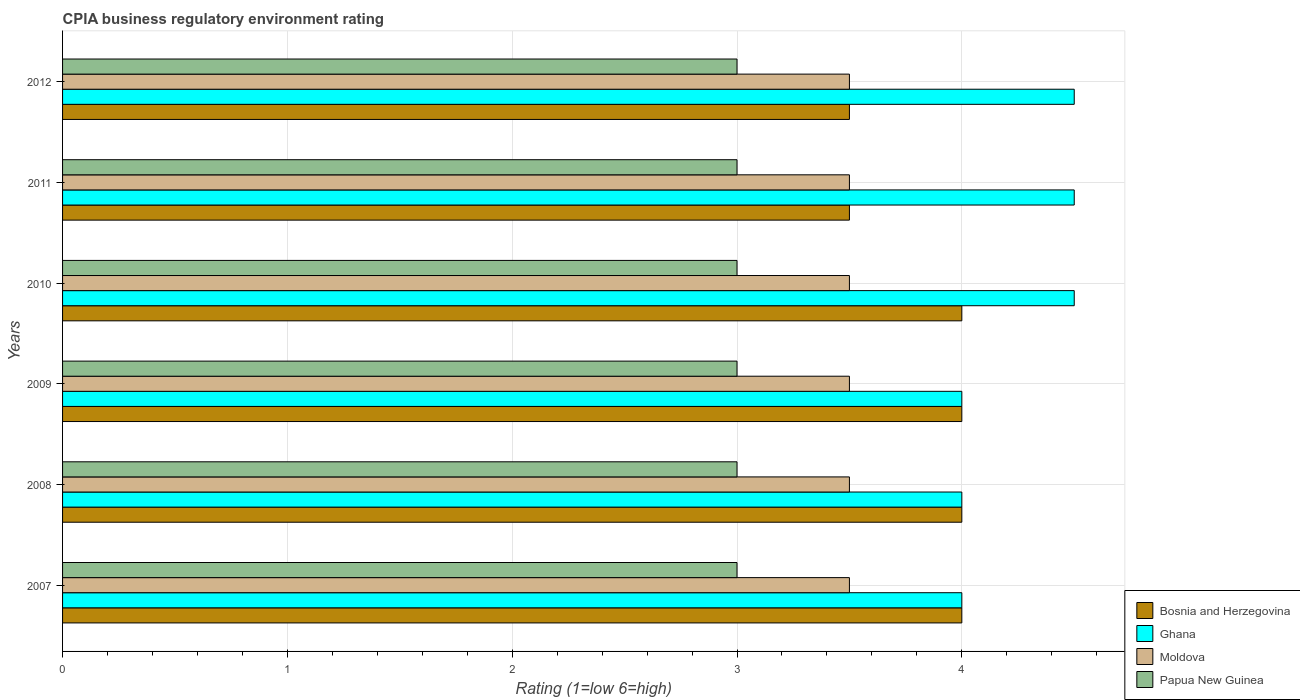How many different coloured bars are there?
Offer a terse response. 4. How many groups of bars are there?
Offer a very short reply. 6. Are the number of bars per tick equal to the number of legend labels?
Provide a succinct answer. Yes. Are the number of bars on each tick of the Y-axis equal?
Offer a very short reply. Yes. In how many cases, is the number of bars for a given year not equal to the number of legend labels?
Provide a succinct answer. 0. What is the CPIA rating in Moldova in 2008?
Your response must be concise. 3.5. Across all years, what is the maximum CPIA rating in Papua New Guinea?
Your answer should be very brief. 3. In which year was the CPIA rating in Papua New Guinea maximum?
Provide a succinct answer. 2007. In which year was the CPIA rating in Papua New Guinea minimum?
Ensure brevity in your answer.  2007. What is the average CPIA rating in Papua New Guinea per year?
Ensure brevity in your answer.  3. In how many years, is the CPIA rating in Ghana greater than 2.8 ?
Keep it short and to the point. 6. Is the CPIA rating in Moldova in 2009 less than that in 2012?
Your answer should be very brief. No. Is the difference between the CPIA rating in Ghana in 2007 and 2011 greater than the difference between the CPIA rating in Papua New Guinea in 2007 and 2011?
Provide a succinct answer. No. What is the difference between the highest and the second highest CPIA rating in Moldova?
Give a very brief answer. 0. What is the difference between the highest and the lowest CPIA rating in Bosnia and Herzegovina?
Give a very brief answer. 0.5. What does the 4th bar from the top in 2010 represents?
Ensure brevity in your answer.  Bosnia and Herzegovina. What does the 3rd bar from the bottom in 2007 represents?
Your answer should be very brief. Moldova. Are all the bars in the graph horizontal?
Your response must be concise. Yes. How many years are there in the graph?
Keep it short and to the point. 6. What is the difference between two consecutive major ticks on the X-axis?
Make the answer very short. 1. How many legend labels are there?
Your answer should be very brief. 4. What is the title of the graph?
Ensure brevity in your answer.  CPIA business regulatory environment rating. What is the label or title of the X-axis?
Provide a short and direct response. Rating (1=low 6=high). What is the Rating (1=low 6=high) of Bosnia and Herzegovina in 2007?
Give a very brief answer. 4. What is the Rating (1=low 6=high) in Ghana in 2007?
Offer a terse response. 4. What is the Rating (1=low 6=high) in Moldova in 2007?
Make the answer very short. 3.5. What is the Rating (1=low 6=high) in Papua New Guinea in 2007?
Ensure brevity in your answer.  3. What is the Rating (1=low 6=high) in Bosnia and Herzegovina in 2008?
Your answer should be very brief. 4. What is the Rating (1=low 6=high) of Ghana in 2008?
Your answer should be very brief. 4. What is the Rating (1=low 6=high) in Papua New Guinea in 2008?
Your response must be concise. 3. What is the Rating (1=low 6=high) in Bosnia and Herzegovina in 2009?
Provide a succinct answer. 4. What is the Rating (1=low 6=high) of Ghana in 2009?
Offer a terse response. 4. What is the Rating (1=low 6=high) in Moldova in 2009?
Your answer should be very brief. 3.5. What is the Rating (1=low 6=high) of Papua New Guinea in 2009?
Provide a short and direct response. 3. What is the Rating (1=low 6=high) of Ghana in 2010?
Your response must be concise. 4.5. What is the Rating (1=low 6=high) in Moldova in 2010?
Your answer should be compact. 3.5. What is the Rating (1=low 6=high) in Papua New Guinea in 2010?
Provide a succinct answer. 3. What is the Rating (1=low 6=high) of Bosnia and Herzegovina in 2011?
Ensure brevity in your answer.  3.5. What is the Rating (1=low 6=high) in Ghana in 2011?
Provide a short and direct response. 4.5. What is the Rating (1=low 6=high) in Papua New Guinea in 2011?
Give a very brief answer. 3. What is the Rating (1=low 6=high) of Bosnia and Herzegovina in 2012?
Your answer should be compact. 3.5. What is the Rating (1=low 6=high) of Moldova in 2012?
Make the answer very short. 3.5. Across all years, what is the maximum Rating (1=low 6=high) of Bosnia and Herzegovina?
Provide a succinct answer. 4. Across all years, what is the minimum Rating (1=low 6=high) in Bosnia and Herzegovina?
Give a very brief answer. 3.5. Across all years, what is the minimum Rating (1=low 6=high) of Papua New Guinea?
Your answer should be compact. 3. What is the total Rating (1=low 6=high) in Ghana in the graph?
Provide a short and direct response. 25.5. What is the difference between the Rating (1=low 6=high) in Ghana in 2007 and that in 2008?
Give a very brief answer. 0. What is the difference between the Rating (1=low 6=high) in Papua New Guinea in 2007 and that in 2008?
Your answer should be very brief. 0. What is the difference between the Rating (1=low 6=high) of Ghana in 2007 and that in 2009?
Provide a short and direct response. 0. What is the difference between the Rating (1=low 6=high) in Bosnia and Herzegovina in 2007 and that in 2010?
Ensure brevity in your answer.  0. What is the difference between the Rating (1=low 6=high) of Ghana in 2007 and that in 2011?
Offer a very short reply. -0.5. What is the difference between the Rating (1=low 6=high) of Moldova in 2007 and that in 2011?
Your response must be concise. 0. What is the difference between the Rating (1=low 6=high) of Papua New Guinea in 2007 and that in 2011?
Make the answer very short. 0. What is the difference between the Rating (1=low 6=high) of Ghana in 2007 and that in 2012?
Your answer should be very brief. -0.5. What is the difference between the Rating (1=low 6=high) of Moldova in 2008 and that in 2009?
Ensure brevity in your answer.  0. What is the difference between the Rating (1=low 6=high) in Papua New Guinea in 2008 and that in 2009?
Your answer should be compact. 0. What is the difference between the Rating (1=low 6=high) in Ghana in 2008 and that in 2010?
Your answer should be very brief. -0.5. What is the difference between the Rating (1=low 6=high) of Moldova in 2008 and that in 2010?
Offer a terse response. 0. What is the difference between the Rating (1=low 6=high) in Ghana in 2008 and that in 2011?
Make the answer very short. -0.5. What is the difference between the Rating (1=low 6=high) in Moldova in 2008 and that in 2011?
Offer a very short reply. 0. What is the difference between the Rating (1=low 6=high) in Papua New Guinea in 2008 and that in 2011?
Offer a terse response. 0. What is the difference between the Rating (1=low 6=high) of Bosnia and Herzegovina in 2008 and that in 2012?
Make the answer very short. 0.5. What is the difference between the Rating (1=low 6=high) in Ghana in 2008 and that in 2012?
Make the answer very short. -0.5. What is the difference between the Rating (1=low 6=high) of Ghana in 2009 and that in 2010?
Give a very brief answer. -0.5. What is the difference between the Rating (1=low 6=high) of Ghana in 2009 and that in 2011?
Make the answer very short. -0.5. What is the difference between the Rating (1=low 6=high) in Papua New Guinea in 2009 and that in 2011?
Your answer should be compact. 0. What is the difference between the Rating (1=low 6=high) in Ghana in 2009 and that in 2012?
Provide a short and direct response. -0.5. What is the difference between the Rating (1=low 6=high) in Moldova in 2009 and that in 2012?
Provide a short and direct response. 0. What is the difference between the Rating (1=low 6=high) in Papua New Guinea in 2009 and that in 2012?
Ensure brevity in your answer.  0. What is the difference between the Rating (1=low 6=high) in Ghana in 2010 and that in 2011?
Offer a very short reply. 0. What is the difference between the Rating (1=low 6=high) in Moldova in 2010 and that in 2011?
Give a very brief answer. 0. What is the difference between the Rating (1=low 6=high) of Bosnia and Herzegovina in 2010 and that in 2012?
Your answer should be compact. 0.5. What is the difference between the Rating (1=low 6=high) of Ghana in 2010 and that in 2012?
Provide a succinct answer. 0. What is the difference between the Rating (1=low 6=high) in Papua New Guinea in 2010 and that in 2012?
Your answer should be very brief. 0. What is the difference between the Rating (1=low 6=high) in Bosnia and Herzegovina in 2011 and that in 2012?
Your answer should be very brief. 0. What is the difference between the Rating (1=low 6=high) of Moldova in 2011 and that in 2012?
Ensure brevity in your answer.  0. What is the difference between the Rating (1=low 6=high) of Bosnia and Herzegovina in 2007 and the Rating (1=low 6=high) of Ghana in 2008?
Offer a terse response. 0. What is the difference between the Rating (1=low 6=high) of Bosnia and Herzegovina in 2007 and the Rating (1=low 6=high) of Papua New Guinea in 2008?
Ensure brevity in your answer.  1. What is the difference between the Rating (1=low 6=high) in Ghana in 2007 and the Rating (1=low 6=high) in Moldova in 2008?
Make the answer very short. 0.5. What is the difference between the Rating (1=low 6=high) in Ghana in 2007 and the Rating (1=low 6=high) in Papua New Guinea in 2008?
Keep it short and to the point. 1. What is the difference between the Rating (1=low 6=high) of Bosnia and Herzegovina in 2007 and the Rating (1=low 6=high) of Moldova in 2009?
Your response must be concise. 0.5. What is the difference between the Rating (1=low 6=high) of Bosnia and Herzegovina in 2007 and the Rating (1=low 6=high) of Papua New Guinea in 2009?
Make the answer very short. 1. What is the difference between the Rating (1=low 6=high) in Ghana in 2007 and the Rating (1=low 6=high) in Moldova in 2009?
Keep it short and to the point. 0.5. What is the difference between the Rating (1=low 6=high) of Bosnia and Herzegovina in 2007 and the Rating (1=low 6=high) of Ghana in 2010?
Provide a succinct answer. -0.5. What is the difference between the Rating (1=low 6=high) in Bosnia and Herzegovina in 2007 and the Rating (1=low 6=high) in Moldova in 2010?
Provide a succinct answer. 0.5. What is the difference between the Rating (1=low 6=high) of Ghana in 2007 and the Rating (1=low 6=high) of Papua New Guinea in 2010?
Give a very brief answer. 1. What is the difference between the Rating (1=low 6=high) in Moldova in 2007 and the Rating (1=low 6=high) in Papua New Guinea in 2010?
Offer a terse response. 0.5. What is the difference between the Rating (1=low 6=high) of Ghana in 2007 and the Rating (1=low 6=high) of Papua New Guinea in 2011?
Make the answer very short. 1. What is the difference between the Rating (1=low 6=high) in Moldova in 2007 and the Rating (1=low 6=high) in Papua New Guinea in 2011?
Provide a short and direct response. 0.5. What is the difference between the Rating (1=low 6=high) of Bosnia and Herzegovina in 2007 and the Rating (1=low 6=high) of Ghana in 2012?
Provide a short and direct response. -0.5. What is the difference between the Rating (1=low 6=high) of Bosnia and Herzegovina in 2007 and the Rating (1=low 6=high) of Moldova in 2012?
Make the answer very short. 0.5. What is the difference between the Rating (1=low 6=high) of Bosnia and Herzegovina in 2007 and the Rating (1=low 6=high) of Papua New Guinea in 2012?
Give a very brief answer. 1. What is the difference between the Rating (1=low 6=high) in Ghana in 2007 and the Rating (1=low 6=high) in Moldova in 2012?
Offer a very short reply. 0.5. What is the difference between the Rating (1=low 6=high) in Moldova in 2007 and the Rating (1=low 6=high) in Papua New Guinea in 2012?
Your answer should be compact. 0.5. What is the difference between the Rating (1=low 6=high) in Bosnia and Herzegovina in 2008 and the Rating (1=low 6=high) in Ghana in 2009?
Your answer should be very brief. 0. What is the difference between the Rating (1=low 6=high) in Bosnia and Herzegovina in 2008 and the Rating (1=low 6=high) in Moldova in 2009?
Provide a short and direct response. 0.5. What is the difference between the Rating (1=low 6=high) in Bosnia and Herzegovina in 2008 and the Rating (1=low 6=high) in Papua New Guinea in 2009?
Your answer should be compact. 1. What is the difference between the Rating (1=low 6=high) of Ghana in 2008 and the Rating (1=low 6=high) of Moldova in 2009?
Provide a short and direct response. 0.5. What is the difference between the Rating (1=low 6=high) in Moldova in 2008 and the Rating (1=low 6=high) in Papua New Guinea in 2009?
Provide a short and direct response. 0.5. What is the difference between the Rating (1=low 6=high) of Bosnia and Herzegovina in 2008 and the Rating (1=low 6=high) of Papua New Guinea in 2010?
Ensure brevity in your answer.  1. What is the difference between the Rating (1=low 6=high) of Ghana in 2008 and the Rating (1=low 6=high) of Papua New Guinea in 2010?
Your answer should be very brief. 1. What is the difference between the Rating (1=low 6=high) in Bosnia and Herzegovina in 2008 and the Rating (1=low 6=high) in Ghana in 2011?
Your response must be concise. -0.5. What is the difference between the Rating (1=low 6=high) in Bosnia and Herzegovina in 2008 and the Rating (1=low 6=high) in Moldova in 2011?
Your response must be concise. 0.5. What is the difference between the Rating (1=low 6=high) in Bosnia and Herzegovina in 2008 and the Rating (1=low 6=high) in Papua New Guinea in 2011?
Keep it short and to the point. 1. What is the difference between the Rating (1=low 6=high) of Ghana in 2008 and the Rating (1=low 6=high) of Papua New Guinea in 2011?
Your response must be concise. 1. What is the difference between the Rating (1=low 6=high) of Moldova in 2008 and the Rating (1=low 6=high) of Papua New Guinea in 2011?
Offer a terse response. 0.5. What is the difference between the Rating (1=low 6=high) in Bosnia and Herzegovina in 2008 and the Rating (1=low 6=high) in Ghana in 2012?
Ensure brevity in your answer.  -0.5. What is the difference between the Rating (1=low 6=high) of Bosnia and Herzegovina in 2008 and the Rating (1=low 6=high) of Moldova in 2012?
Offer a very short reply. 0.5. What is the difference between the Rating (1=low 6=high) in Bosnia and Herzegovina in 2008 and the Rating (1=low 6=high) in Papua New Guinea in 2012?
Provide a succinct answer. 1. What is the difference between the Rating (1=low 6=high) of Ghana in 2008 and the Rating (1=low 6=high) of Moldova in 2012?
Make the answer very short. 0.5. What is the difference between the Rating (1=low 6=high) of Ghana in 2008 and the Rating (1=low 6=high) of Papua New Guinea in 2012?
Provide a succinct answer. 1. What is the difference between the Rating (1=low 6=high) of Bosnia and Herzegovina in 2009 and the Rating (1=low 6=high) of Papua New Guinea in 2010?
Keep it short and to the point. 1. What is the difference between the Rating (1=low 6=high) in Ghana in 2009 and the Rating (1=low 6=high) in Moldova in 2010?
Ensure brevity in your answer.  0.5. What is the difference between the Rating (1=low 6=high) in Moldova in 2009 and the Rating (1=low 6=high) in Papua New Guinea in 2010?
Make the answer very short. 0.5. What is the difference between the Rating (1=low 6=high) in Bosnia and Herzegovina in 2009 and the Rating (1=low 6=high) in Papua New Guinea in 2011?
Offer a terse response. 1. What is the difference between the Rating (1=low 6=high) of Ghana in 2009 and the Rating (1=low 6=high) of Moldova in 2011?
Your answer should be compact. 0.5. What is the difference between the Rating (1=low 6=high) in Moldova in 2009 and the Rating (1=low 6=high) in Papua New Guinea in 2011?
Offer a terse response. 0.5. What is the difference between the Rating (1=low 6=high) of Bosnia and Herzegovina in 2009 and the Rating (1=low 6=high) of Ghana in 2012?
Ensure brevity in your answer.  -0.5. What is the difference between the Rating (1=low 6=high) in Bosnia and Herzegovina in 2009 and the Rating (1=low 6=high) in Moldova in 2012?
Your answer should be very brief. 0.5. What is the difference between the Rating (1=low 6=high) of Bosnia and Herzegovina in 2009 and the Rating (1=low 6=high) of Papua New Guinea in 2012?
Offer a very short reply. 1. What is the difference between the Rating (1=low 6=high) of Ghana in 2009 and the Rating (1=low 6=high) of Moldova in 2012?
Provide a succinct answer. 0.5. What is the difference between the Rating (1=low 6=high) of Ghana in 2009 and the Rating (1=low 6=high) of Papua New Guinea in 2012?
Your response must be concise. 1. What is the difference between the Rating (1=low 6=high) in Bosnia and Herzegovina in 2010 and the Rating (1=low 6=high) in Ghana in 2011?
Your response must be concise. -0.5. What is the difference between the Rating (1=low 6=high) in Bosnia and Herzegovina in 2010 and the Rating (1=low 6=high) in Papua New Guinea in 2011?
Provide a succinct answer. 1. What is the difference between the Rating (1=low 6=high) in Bosnia and Herzegovina in 2010 and the Rating (1=low 6=high) in Moldova in 2012?
Your response must be concise. 0.5. What is the difference between the Rating (1=low 6=high) of Moldova in 2010 and the Rating (1=low 6=high) of Papua New Guinea in 2012?
Keep it short and to the point. 0.5. What is the difference between the Rating (1=low 6=high) in Bosnia and Herzegovina in 2011 and the Rating (1=low 6=high) in Ghana in 2012?
Your response must be concise. -1. What is the difference between the Rating (1=low 6=high) in Bosnia and Herzegovina in 2011 and the Rating (1=low 6=high) in Papua New Guinea in 2012?
Offer a very short reply. 0.5. What is the difference between the Rating (1=low 6=high) of Ghana in 2011 and the Rating (1=low 6=high) of Moldova in 2012?
Your response must be concise. 1. What is the average Rating (1=low 6=high) in Bosnia and Herzegovina per year?
Ensure brevity in your answer.  3.83. What is the average Rating (1=low 6=high) of Ghana per year?
Your response must be concise. 4.25. What is the average Rating (1=low 6=high) of Papua New Guinea per year?
Provide a short and direct response. 3. In the year 2007, what is the difference between the Rating (1=low 6=high) of Bosnia and Herzegovina and Rating (1=low 6=high) of Moldova?
Your response must be concise. 0.5. In the year 2007, what is the difference between the Rating (1=low 6=high) in Bosnia and Herzegovina and Rating (1=low 6=high) in Papua New Guinea?
Provide a short and direct response. 1. In the year 2007, what is the difference between the Rating (1=low 6=high) of Ghana and Rating (1=low 6=high) of Moldova?
Provide a succinct answer. 0.5. In the year 2008, what is the difference between the Rating (1=low 6=high) in Bosnia and Herzegovina and Rating (1=low 6=high) in Ghana?
Provide a short and direct response. 0. In the year 2008, what is the difference between the Rating (1=low 6=high) in Bosnia and Herzegovina and Rating (1=low 6=high) in Papua New Guinea?
Provide a short and direct response. 1. In the year 2008, what is the difference between the Rating (1=low 6=high) of Ghana and Rating (1=low 6=high) of Papua New Guinea?
Ensure brevity in your answer.  1. In the year 2008, what is the difference between the Rating (1=low 6=high) of Moldova and Rating (1=low 6=high) of Papua New Guinea?
Ensure brevity in your answer.  0.5. In the year 2009, what is the difference between the Rating (1=low 6=high) in Bosnia and Herzegovina and Rating (1=low 6=high) in Ghana?
Offer a very short reply. 0. In the year 2009, what is the difference between the Rating (1=low 6=high) of Bosnia and Herzegovina and Rating (1=low 6=high) of Moldova?
Your answer should be very brief. 0.5. In the year 2009, what is the difference between the Rating (1=low 6=high) of Moldova and Rating (1=low 6=high) of Papua New Guinea?
Provide a short and direct response. 0.5. In the year 2010, what is the difference between the Rating (1=low 6=high) of Bosnia and Herzegovina and Rating (1=low 6=high) of Ghana?
Provide a succinct answer. -0.5. In the year 2010, what is the difference between the Rating (1=low 6=high) of Bosnia and Herzegovina and Rating (1=low 6=high) of Papua New Guinea?
Ensure brevity in your answer.  1. In the year 2010, what is the difference between the Rating (1=low 6=high) of Ghana and Rating (1=low 6=high) of Moldova?
Give a very brief answer. 1. In the year 2010, what is the difference between the Rating (1=low 6=high) in Ghana and Rating (1=low 6=high) in Papua New Guinea?
Give a very brief answer. 1.5. In the year 2011, what is the difference between the Rating (1=low 6=high) in Bosnia and Herzegovina and Rating (1=low 6=high) in Moldova?
Your answer should be compact. 0. In the year 2012, what is the difference between the Rating (1=low 6=high) in Bosnia and Herzegovina and Rating (1=low 6=high) in Ghana?
Offer a very short reply. -1. In the year 2012, what is the difference between the Rating (1=low 6=high) of Bosnia and Herzegovina and Rating (1=low 6=high) of Moldova?
Make the answer very short. 0. In the year 2012, what is the difference between the Rating (1=low 6=high) in Bosnia and Herzegovina and Rating (1=low 6=high) in Papua New Guinea?
Your answer should be very brief. 0.5. In the year 2012, what is the difference between the Rating (1=low 6=high) in Ghana and Rating (1=low 6=high) in Moldova?
Ensure brevity in your answer.  1. In the year 2012, what is the difference between the Rating (1=low 6=high) in Moldova and Rating (1=low 6=high) in Papua New Guinea?
Provide a short and direct response. 0.5. What is the ratio of the Rating (1=low 6=high) in Ghana in 2007 to that in 2008?
Your response must be concise. 1. What is the ratio of the Rating (1=low 6=high) of Papua New Guinea in 2007 to that in 2008?
Your response must be concise. 1. What is the ratio of the Rating (1=low 6=high) of Ghana in 2007 to that in 2009?
Make the answer very short. 1. What is the ratio of the Rating (1=low 6=high) in Moldova in 2007 to that in 2011?
Your answer should be very brief. 1. What is the ratio of the Rating (1=low 6=high) of Ghana in 2007 to that in 2012?
Offer a terse response. 0.89. What is the ratio of the Rating (1=low 6=high) of Moldova in 2007 to that in 2012?
Offer a very short reply. 1. What is the ratio of the Rating (1=low 6=high) of Papua New Guinea in 2007 to that in 2012?
Ensure brevity in your answer.  1. What is the ratio of the Rating (1=low 6=high) of Bosnia and Herzegovina in 2008 to that in 2010?
Your answer should be very brief. 1. What is the ratio of the Rating (1=low 6=high) in Bosnia and Herzegovina in 2008 to that in 2011?
Ensure brevity in your answer.  1.14. What is the ratio of the Rating (1=low 6=high) of Ghana in 2008 to that in 2011?
Make the answer very short. 0.89. What is the ratio of the Rating (1=low 6=high) in Papua New Guinea in 2008 to that in 2011?
Offer a terse response. 1. What is the ratio of the Rating (1=low 6=high) of Ghana in 2008 to that in 2012?
Ensure brevity in your answer.  0.89. What is the ratio of the Rating (1=low 6=high) in Moldova in 2008 to that in 2012?
Your answer should be very brief. 1. What is the ratio of the Rating (1=low 6=high) in Moldova in 2009 to that in 2010?
Keep it short and to the point. 1. What is the ratio of the Rating (1=low 6=high) in Papua New Guinea in 2009 to that in 2010?
Your answer should be compact. 1. What is the ratio of the Rating (1=low 6=high) of Bosnia and Herzegovina in 2009 to that in 2011?
Offer a very short reply. 1.14. What is the ratio of the Rating (1=low 6=high) of Ghana in 2009 to that in 2011?
Your answer should be compact. 0.89. What is the ratio of the Rating (1=low 6=high) in Moldova in 2009 to that in 2011?
Provide a succinct answer. 1. What is the ratio of the Rating (1=low 6=high) of Papua New Guinea in 2009 to that in 2011?
Keep it short and to the point. 1. What is the ratio of the Rating (1=low 6=high) of Bosnia and Herzegovina in 2009 to that in 2012?
Ensure brevity in your answer.  1.14. What is the ratio of the Rating (1=low 6=high) of Moldova in 2009 to that in 2012?
Keep it short and to the point. 1. What is the ratio of the Rating (1=low 6=high) of Papua New Guinea in 2009 to that in 2012?
Offer a very short reply. 1. What is the ratio of the Rating (1=low 6=high) in Moldova in 2010 to that in 2011?
Ensure brevity in your answer.  1. What is the ratio of the Rating (1=low 6=high) in Papua New Guinea in 2010 to that in 2011?
Ensure brevity in your answer.  1. What is the ratio of the Rating (1=low 6=high) in Bosnia and Herzegovina in 2010 to that in 2012?
Make the answer very short. 1.14. What is the ratio of the Rating (1=low 6=high) of Ghana in 2010 to that in 2012?
Keep it short and to the point. 1. What is the ratio of the Rating (1=low 6=high) in Moldova in 2010 to that in 2012?
Provide a short and direct response. 1. What is the ratio of the Rating (1=low 6=high) of Bosnia and Herzegovina in 2011 to that in 2012?
Provide a short and direct response. 1. What is the ratio of the Rating (1=low 6=high) of Ghana in 2011 to that in 2012?
Offer a very short reply. 1. What is the ratio of the Rating (1=low 6=high) in Papua New Guinea in 2011 to that in 2012?
Your response must be concise. 1. What is the difference between the highest and the second highest Rating (1=low 6=high) of Bosnia and Herzegovina?
Your answer should be compact. 0. What is the difference between the highest and the lowest Rating (1=low 6=high) of Bosnia and Herzegovina?
Offer a terse response. 0.5. What is the difference between the highest and the lowest Rating (1=low 6=high) in Ghana?
Offer a very short reply. 0.5. 